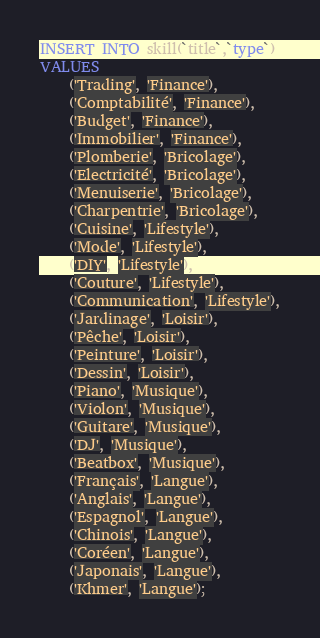<code> <loc_0><loc_0><loc_500><loc_500><_SQL_>INSERT INTO skill(`title`,`type`)
VALUES
    ('Trading', 'Finance'),
    ('Comptabilité', 'Finance'),
    ('Budget', 'Finance'),
    ('Immobilier', 'Finance'),
    ('Plomberie', 'Bricolage'),
    ('Electricité', 'Bricolage'),
    ('Menuiserie', 'Bricolage'),
    ('Charpentrie', 'Bricolage'),
    ('Cuisine', 'Lifestyle'),
    ('Mode', 'Lifestyle'),
    ('DIY', 'Lifestyle'),
    ('Couture', 'Lifestyle'),
    ('Communication', 'Lifestyle'),
    ('Jardinage', 'Loisir'),
    ('Pêche', 'Loisir'),
    ('Peinture', 'Loisir'),
    ('Dessin', 'Loisir'),
    ('Piano', 'Musique'),
    ('Violon', 'Musique'),
    ('Guitare', 'Musique'),
    ('DJ', 'Musique'),
    ('Beatbox', 'Musique'),
    ('Français', 'Langue'),
    ('Anglais', 'Langue'),
    ('Espagnol', 'Langue'),
    ('Chinois', 'Langue'),
    ('Coréen', 'Langue'),
    ('Japonais', 'Langue'),
    ('Khmer', 'Langue');
</code> 